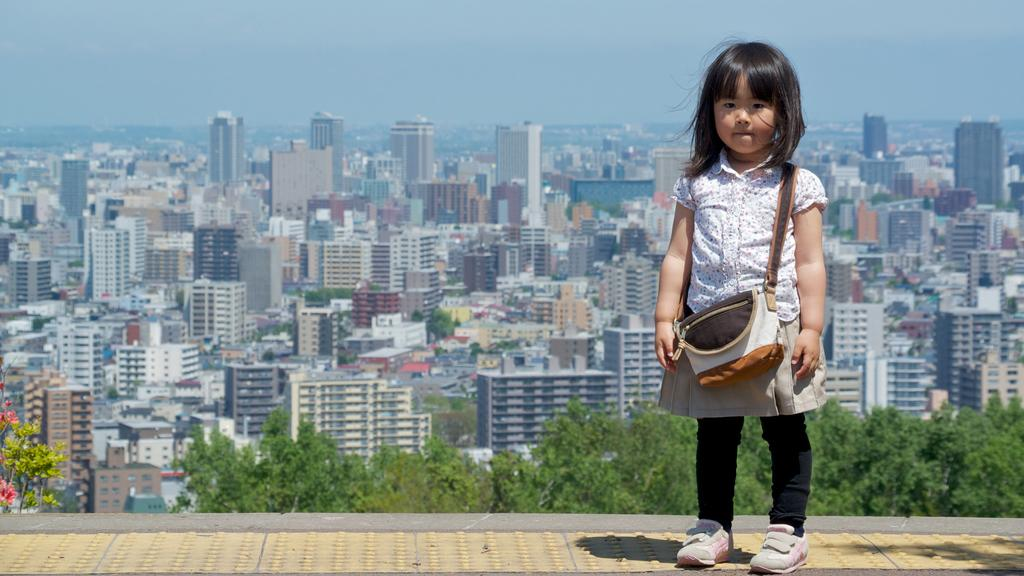Who is the main subject in the image? There is a girl in the image. What is the girl carrying in the image? The girl is carrying a bag. Where is the girl standing in the image? The girl is standing on a path. What type of vegetation can be seen in the image? There are flowers and trees in the image. What can be seen in the background of the image? There are buildings and the sky visible in the background of the image. How many kittens are playing with the lawyer in the crowd in the image? There are no kittens, lawyers, or crowds present in the image. 